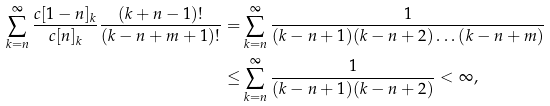<formula> <loc_0><loc_0><loc_500><loc_500>\sum _ { k = n } ^ { \infty } \frac { c [ 1 - n ] _ { k } } { c [ n ] _ { k } } \frac { ( k + n - 1 ) ! } { ( k - n + m + 1 ) ! } = & \sum _ { k = n } ^ { \infty } \frac { 1 } { ( k - n + 1 ) ( k - n + 2 ) \dots ( k - n + m ) } \\ \leq & \sum _ { k = n } ^ { \infty } \frac { 1 } { ( k - n + 1 ) ( k - n + 2 ) } < \infty ,</formula> 